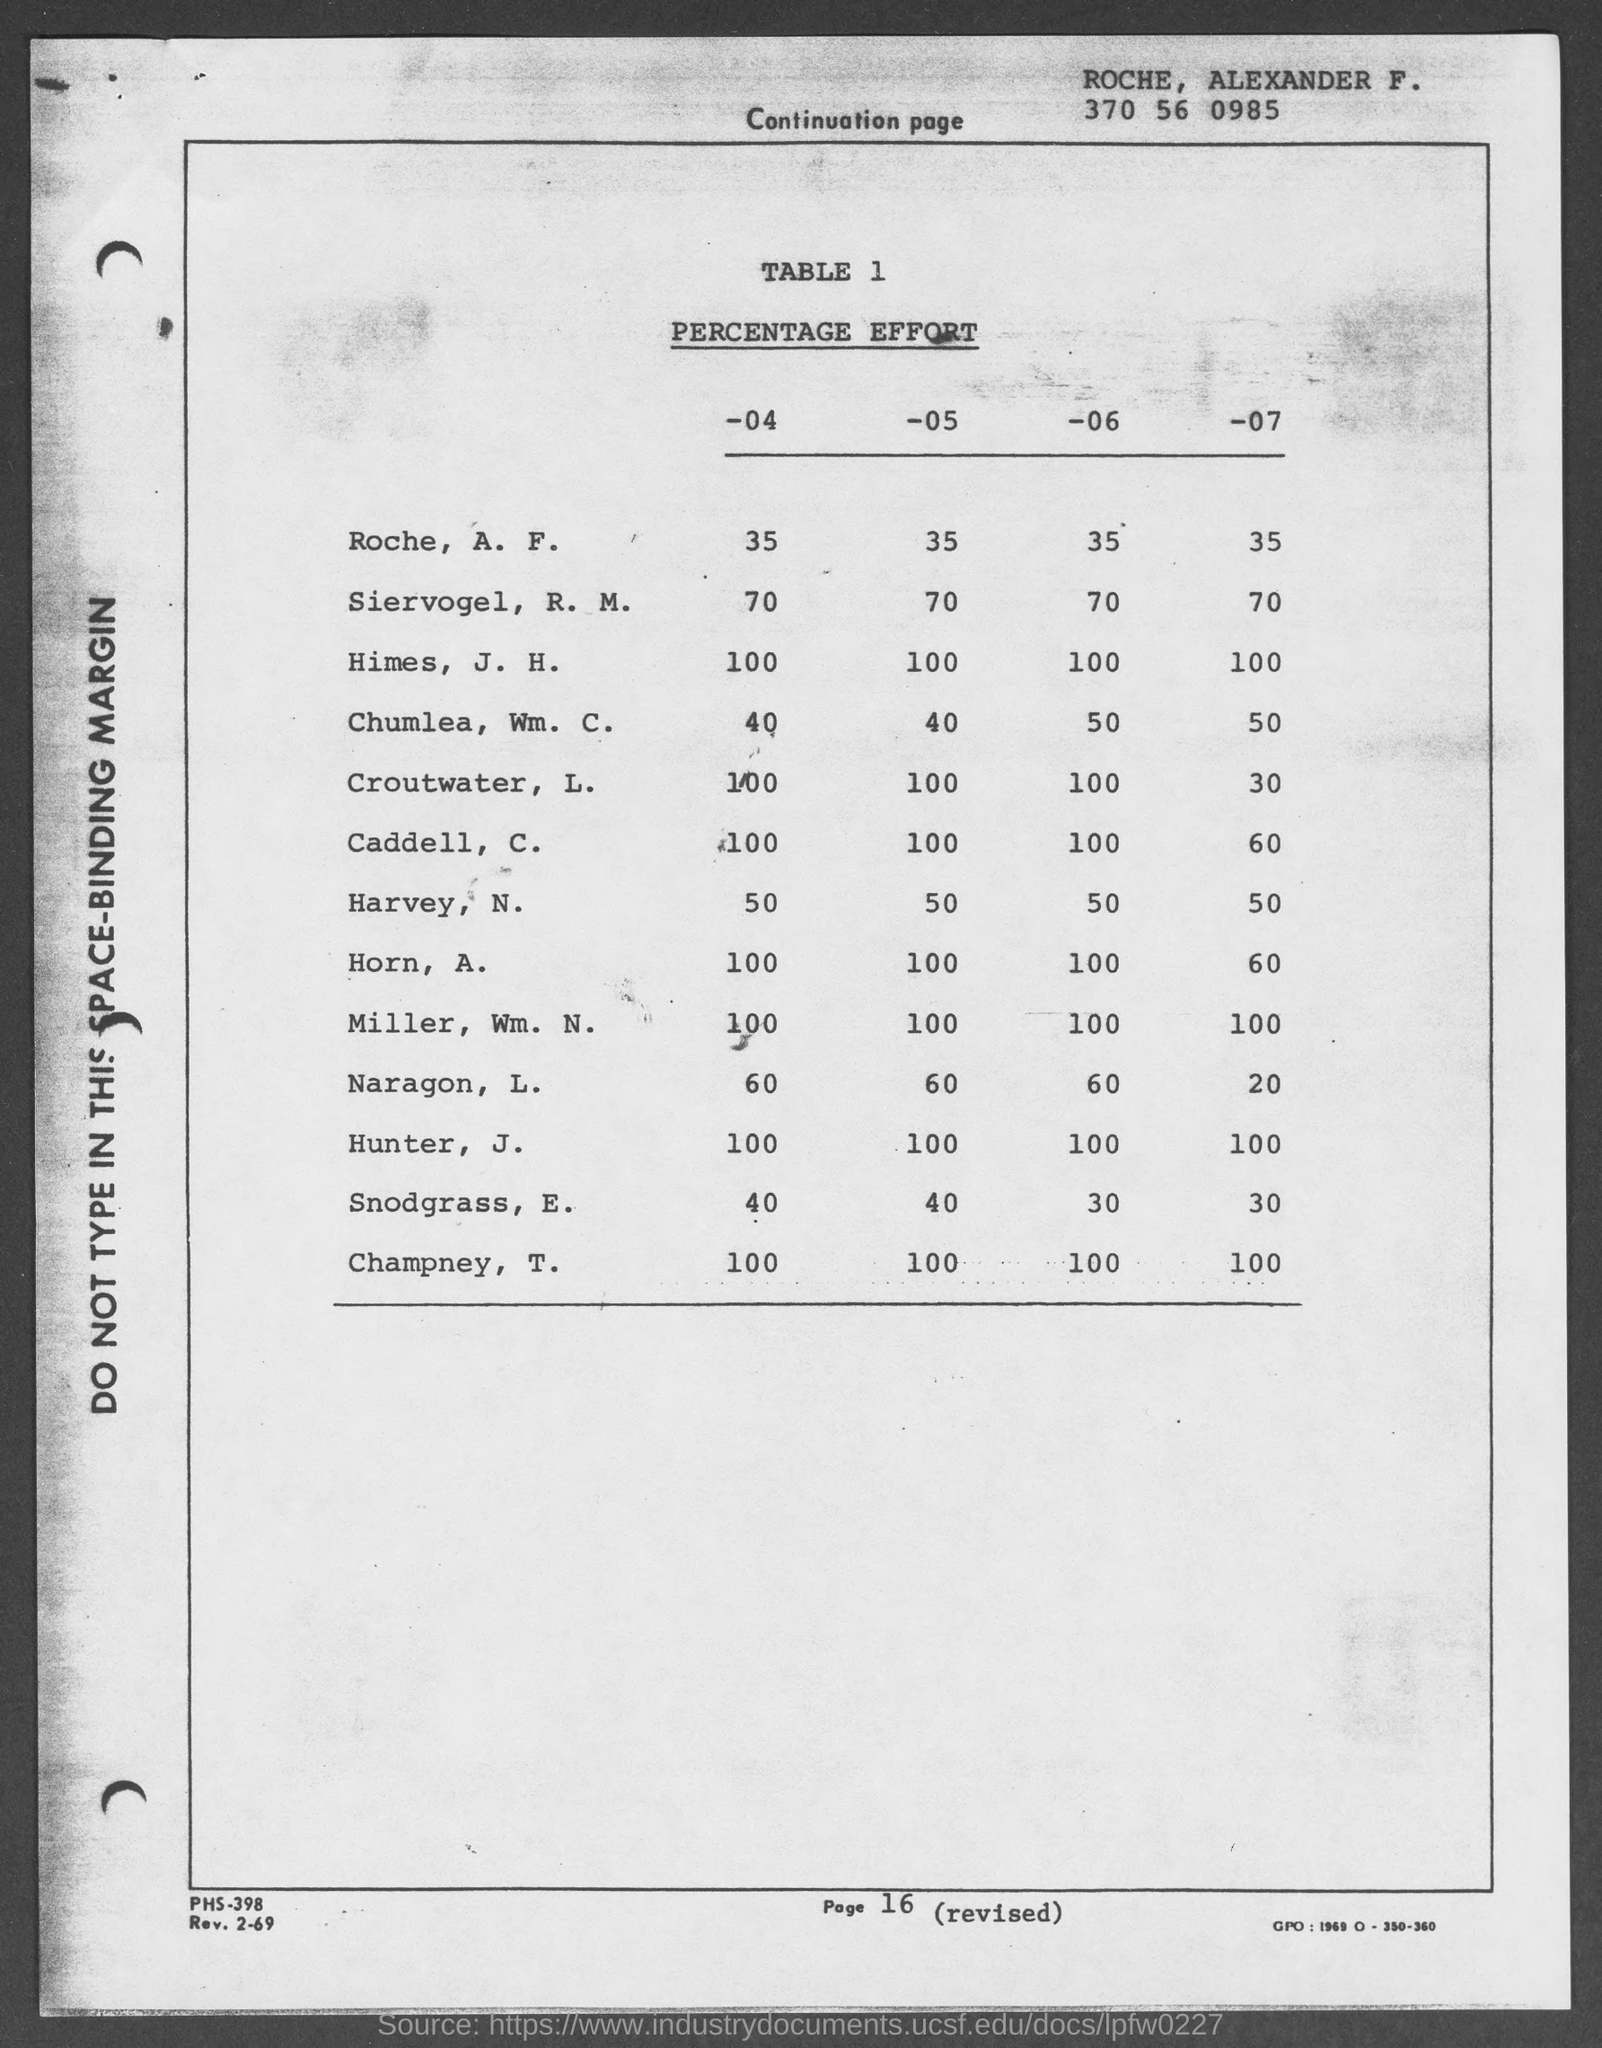Indicate a few pertinent items in this graphic. The name 'ROCHE' is written at the top of the document, followed by 'ALEXANDER F.' and a comma. 